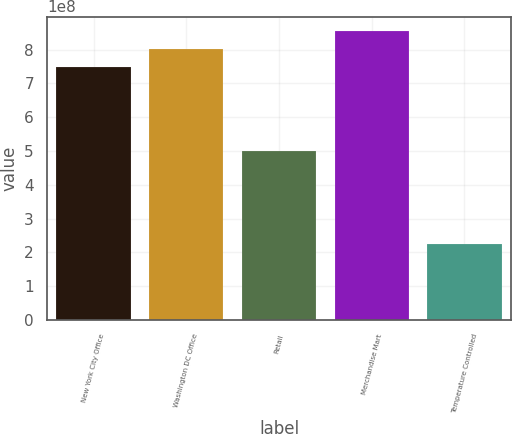<chart> <loc_0><loc_0><loc_500><loc_500><bar_chart><fcel>New York City Office<fcel>Washington DC Office<fcel>Retail<fcel>Merchandise Mart<fcel>Temperature Controlled<nl><fcel>7.5e+08<fcel>8.025e+08<fcel>5e+08<fcel>8.55e+08<fcel>2.25e+08<nl></chart> 